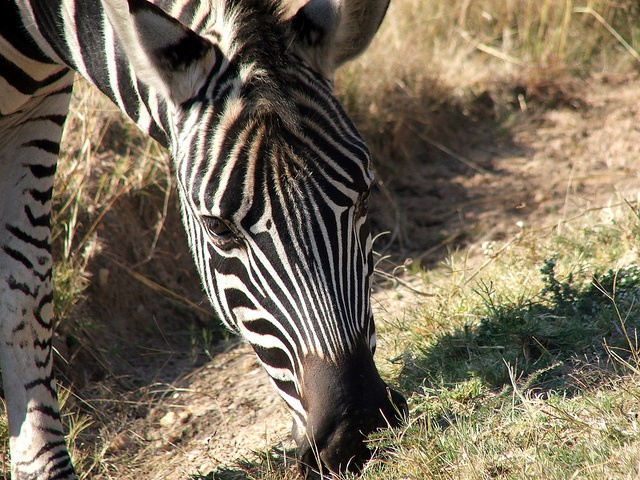Describe the objects in this image and their specific colors. I can see a zebra in black, gray, and ivory tones in this image. 